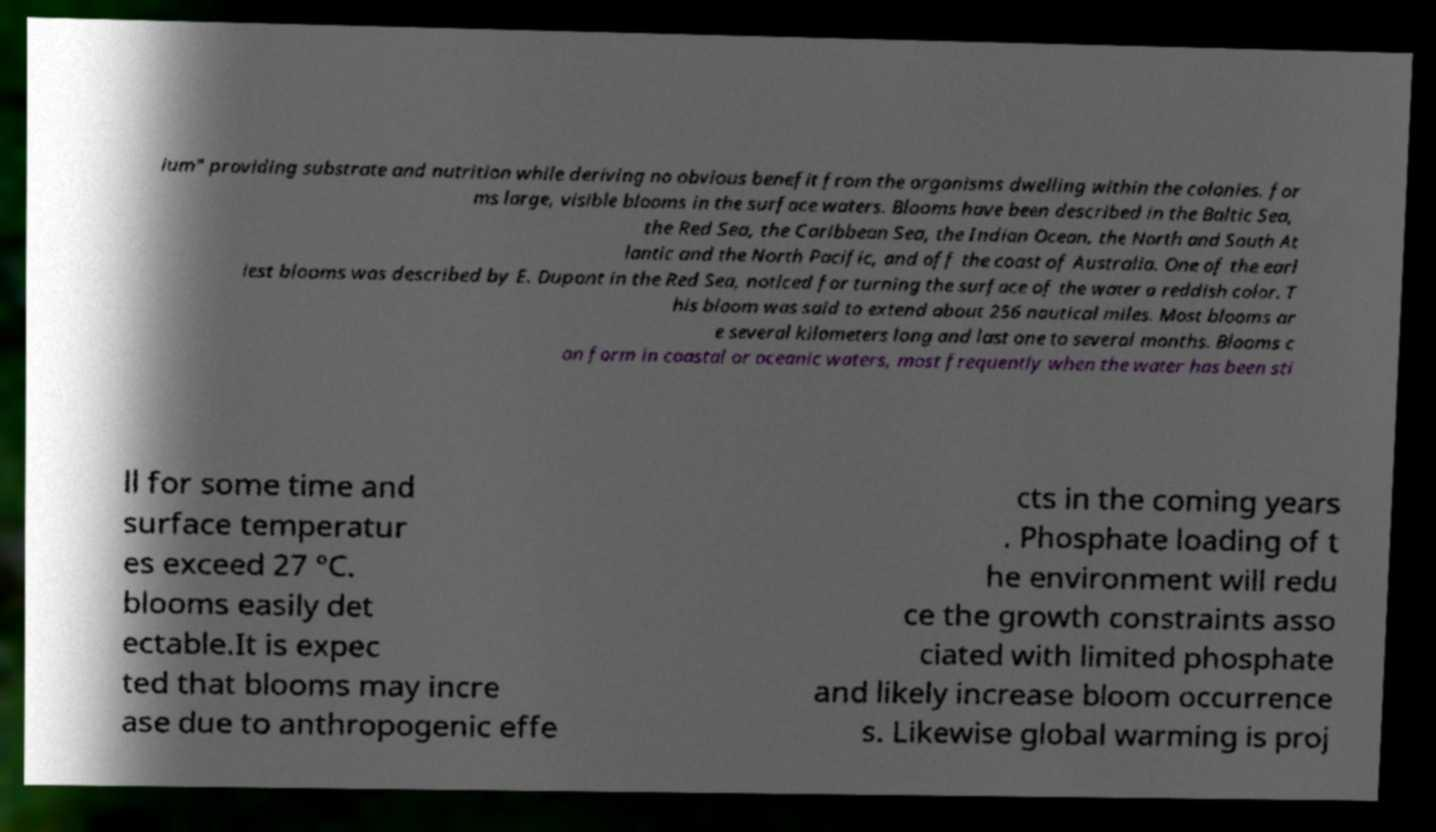Can you accurately transcribe the text from the provided image for me? ium" providing substrate and nutrition while deriving no obvious benefit from the organisms dwelling within the colonies. for ms large, visible blooms in the surface waters. Blooms have been described in the Baltic Sea, the Red Sea, the Caribbean Sea, the Indian Ocean, the North and South At lantic and the North Pacific, and off the coast of Australia. One of the earl iest blooms was described by E. Dupont in the Red Sea, noticed for turning the surface of the water a reddish color. T his bloom was said to extend about 256 nautical miles. Most blooms ar e several kilometers long and last one to several months. Blooms c an form in coastal or oceanic waters, most frequently when the water has been sti ll for some time and surface temperatur es exceed 27 °C. blooms easily det ectable.It is expec ted that blooms may incre ase due to anthropogenic effe cts in the coming years . Phosphate loading of t he environment will redu ce the growth constraints asso ciated with limited phosphate and likely increase bloom occurrence s. Likewise global warming is proj 